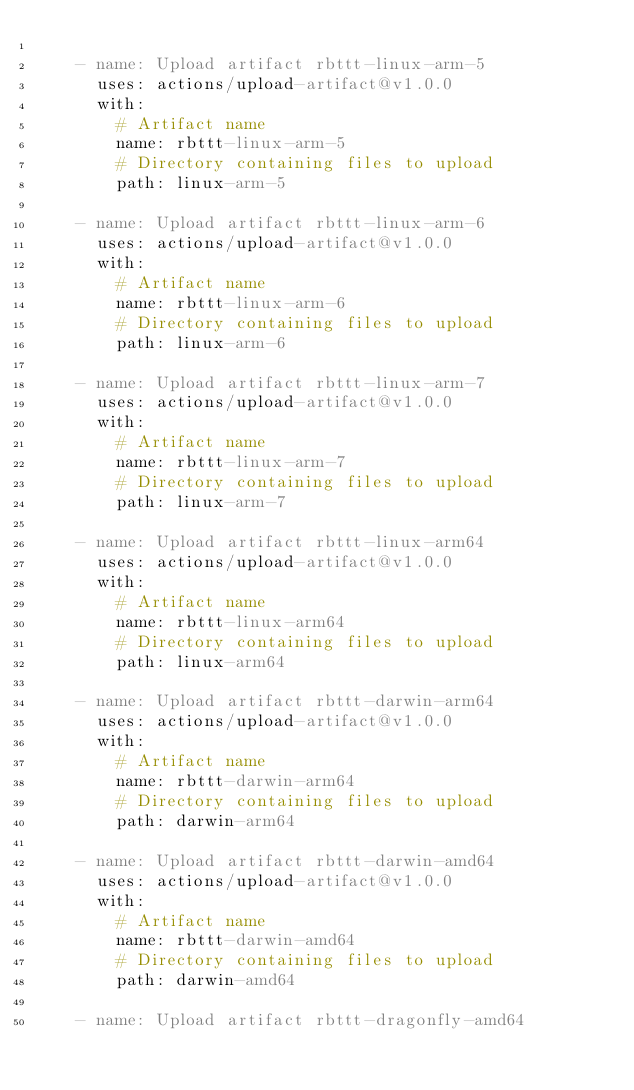Convert code to text. <code><loc_0><loc_0><loc_500><loc_500><_YAML_>
    - name: Upload artifact rbttt-linux-arm-5
      uses: actions/upload-artifact@v1.0.0
      with:
        # Artifact name
        name: rbttt-linux-arm-5
        # Directory containing files to upload
        path: linux-arm-5

    - name: Upload artifact rbttt-linux-arm-6
      uses: actions/upload-artifact@v1.0.0
      with:
        # Artifact name
        name: rbttt-linux-arm-6
        # Directory containing files to upload
        path: linux-arm-6

    - name: Upload artifact rbttt-linux-arm-7
      uses: actions/upload-artifact@v1.0.0
      with:
        # Artifact name
        name: rbttt-linux-arm-7
        # Directory containing files to upload
        path: linux-arm-7

    - name: Upload artifact rbttt-linux-arm64
      uses: actions/upload-artifact@v1.0.0
      with:
        # Artifact name
        name: rbttt-linux-arm64
        # Directory containing files to upload
        path: linux-arm64

    - name: Upload artifact rbttt-darwin-arm64
      uses: actions/upload-artifact@v1.0.0
      with:
        # Artifact name
        name: rbttt-darwin-arm64
        # Directory containing files to upload
        path: darwin-arm64

    - name: Upload artifact rbttt-darwin-amd64
      uses: actions/upload-artifact@v1.0.0
      with:
        # Artifact name
        name: rbttt-darwin-amd64
        # Directory containing files to upload
        path: darwin-amd64

    - name: Upload artifact rbttt-dragonfly-amd64</code> 